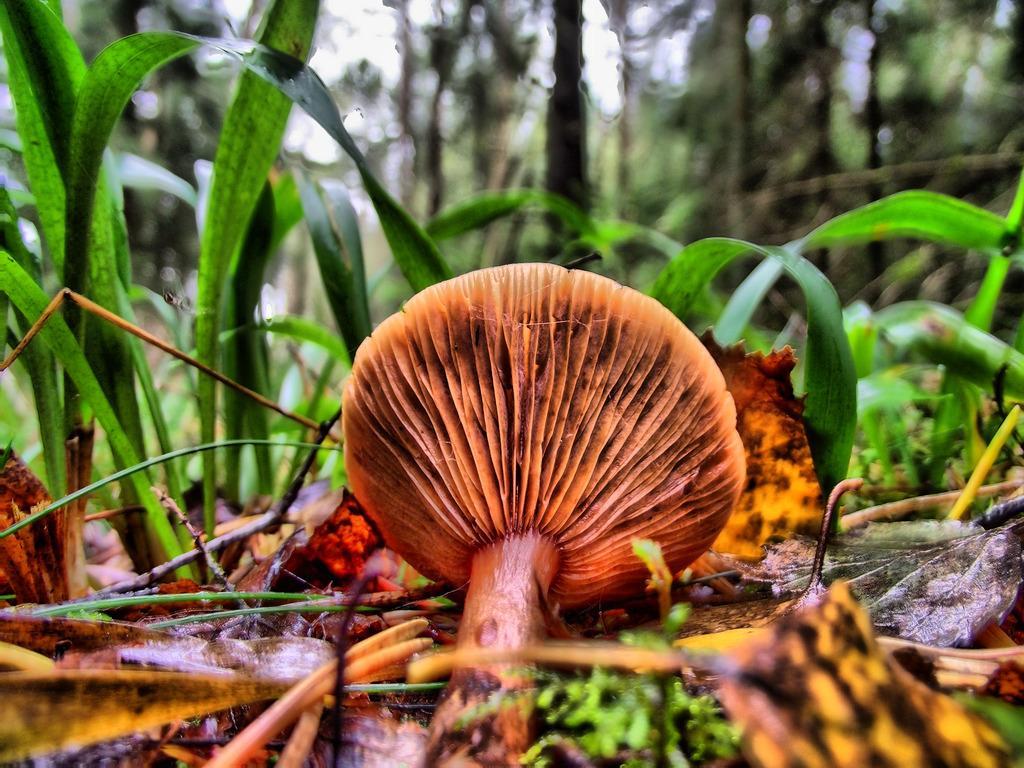Could you give a brief overview of what you see in this image? In this image there is a mushroom on the land having few plants, leaves and trees on it. Background there are few trees. 